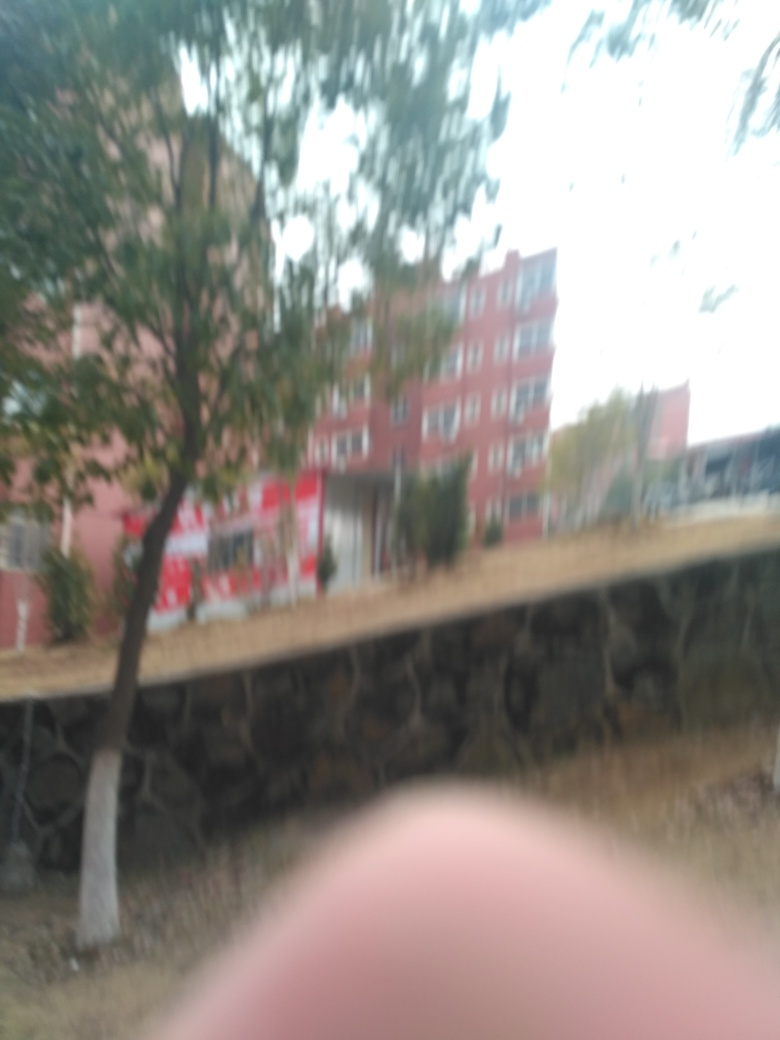How is the overall sharpness of this image? The overall sharpness of this image is very low, which is evident from the noticeable blur and lack of clear details, making it difficult to discern specific elements in the photograph. 